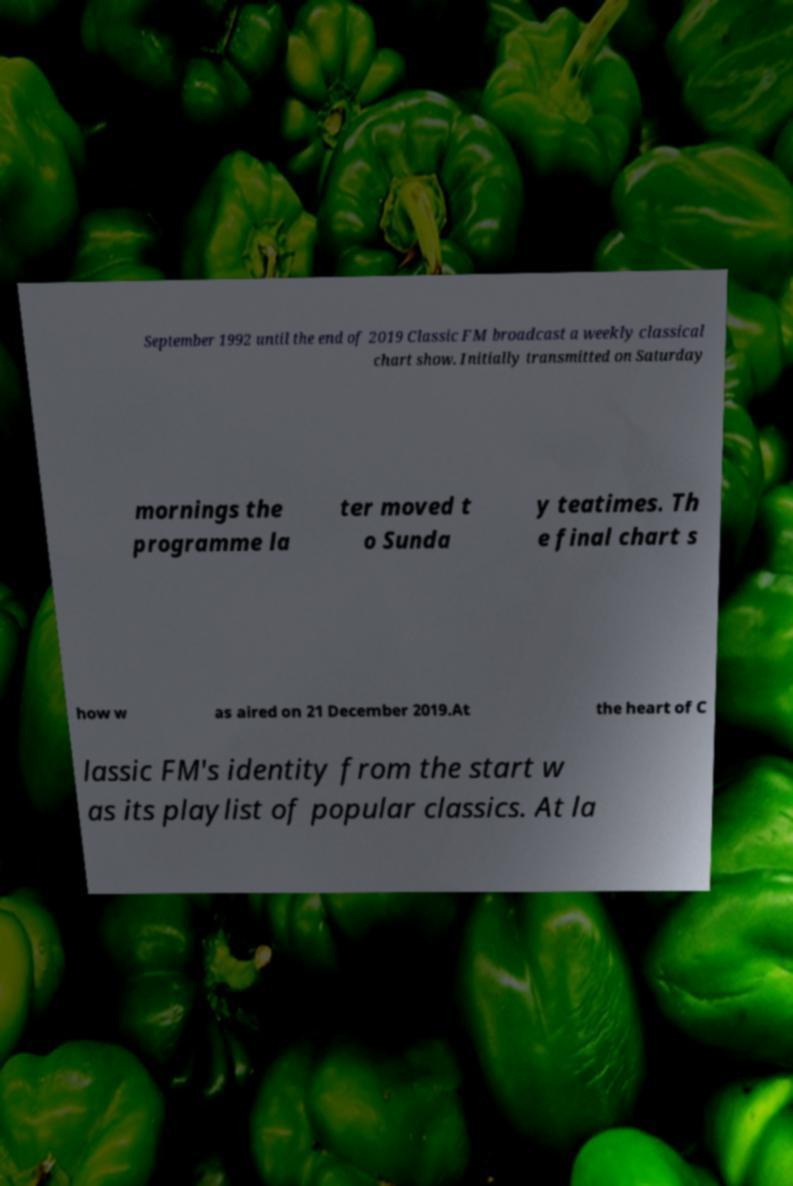There's text embedded in this image that I need extracted. Can you transcribe it verbatim? September 1992 until the end of 2019 Classic FM broadcast a weekly classical chart show. Initially transmitted on Saturday mornings the programme la ter moved t o Sunda y teatimes. Th e final chart s how w as aired on 21 December 2019.At the heart of C lassic FM's identity from the start w as its playlist of popular classics. At la 